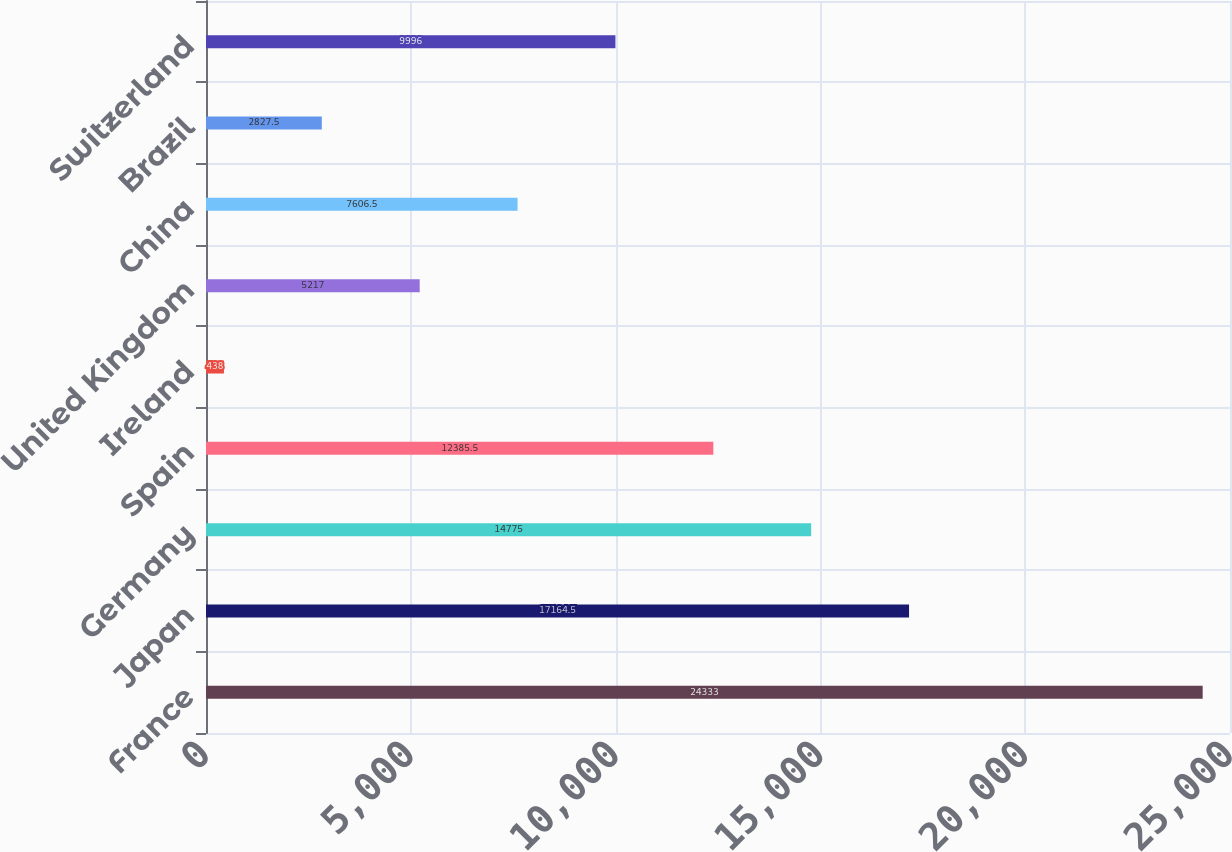Convert chart. <chart><loc_0><loc_0><loc_500><loc_500><bar_chart><fcel>France<fcel>Japan<fcel>Germany<fcel>Spain<fcel>Ireland<fcel>United Kingdom<fcel>China<fcel>Brazil<fcel>Switzerland<nl><fcel>24333<fcel>17164.5<fcel>14775<fcel>12385.5<fcel>438<fcel>5217<fcel>7606.5<fcel>2827.5<fcel>9996<nl></chart> 